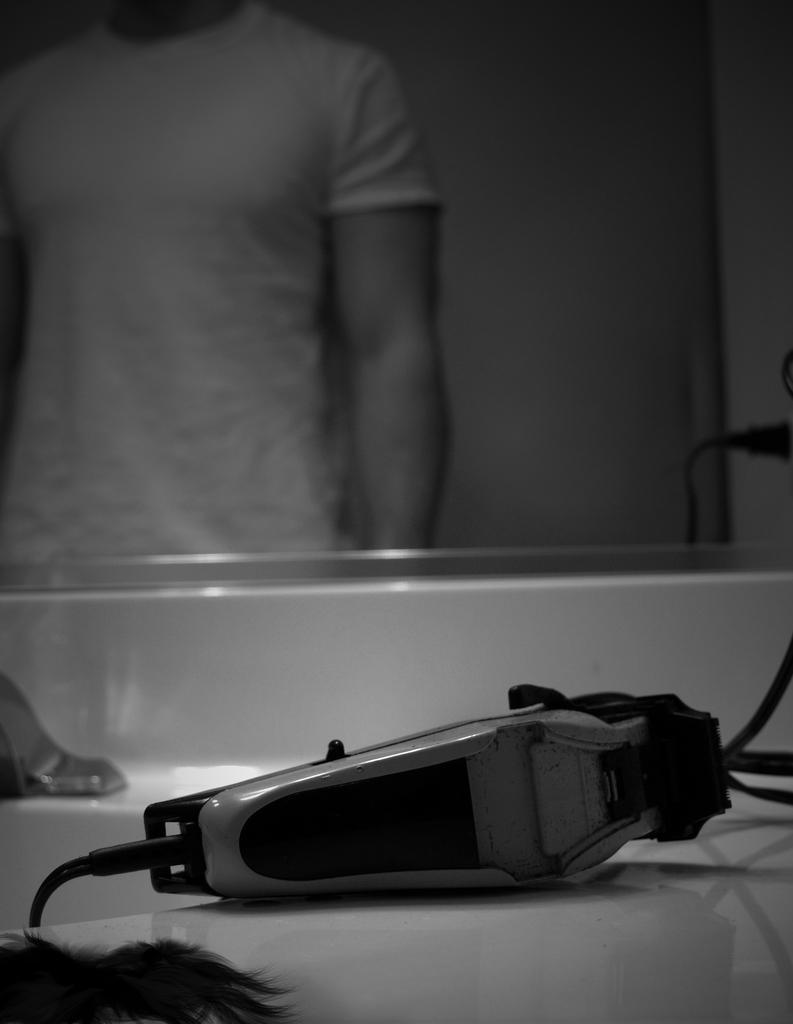Could you give a brief overview of what you see in this image? It is a black and white image, there is some object in the foreground and behind the object there is a mirror, in the mirror it looks like there is some person is standing. 